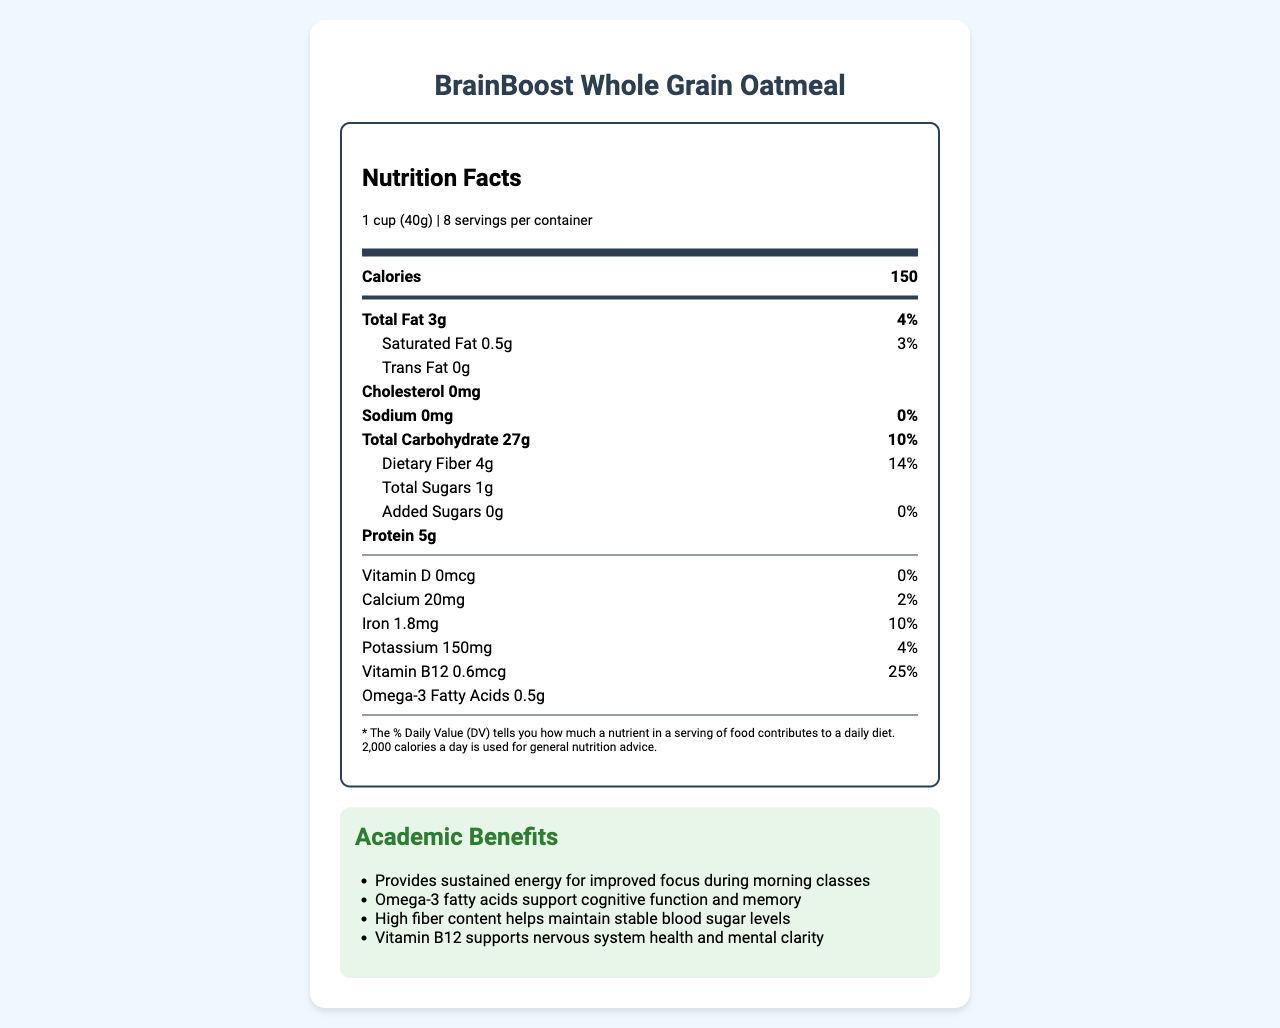who is the manufacturer of the BrainBoost Whole Grain Oatmeal? The manufacturer is listed at the end of the document under the "manufacturer" section.
Answer: NutriSmart Foods, Inc. what is the serving size of the BrainBoost Whole Grain Oatmeal? The serving size is noted near the top of the nutrition label.
Answer: 1 cup (40g) how much dietary fiber is in one serving? The amount of dietary fiber is listed under the "Total Carbohydrate" section in the nutrition facts.
Answer: 4g what is the daily value percentage for iron? The daily value percentage for iron is listed under the "Iron" section in the nutrition facts.
Answer: 10% how many servings are there per container? The number of servings per container is indicated at the top of the nutrition label.
Answer: 8 which vitamin is specifically mentioned as supporting nervous system health and mental clarity?  
A. Vitamin D  
B. Calcium  
C. Vitamin B12 Vitamin B12 is the vitamin specifically mentioned for supporting nervous system health and mental clarity based on the academic benefits section.
Answer: C which of the following health claims is true about the BrainBoost Whole Grain Oatmeal?  
I. High in sodium  
II. Contains omega-3 fatty acids for brain health  
III. No added sugars  
IV. Excellent source of whole grains The health claims are listed near the bottom and "Contains omega-3 fatty acids for brain health," "No added sugars," and "Excellent source of whole grains" are true. "High in sodium" is false.
Answer: II, III, IV is BrainBoost Whole Grain Oatmeal Non-GMO? The certification section mentions that the product is Non-GMO Project Verified.
Answer: Yes does the product contain any trans fat? The nutrition facts explicitly state that the product contains 0g of trans fat.
Answer: No summarize the main academic benefits of BrainBoost Whole Grain Oatmeal. The academic benefits section lists several benefits: sustained energy, cognitive support from omega-3 fatty acids, stable blood sugar management from fiber, and nervous system and mental clarity support from Vitamin B12.
Answer: The main academic benefits include providing sustained energy for improved focus during morning classes, supporting cognitive function and memory with omega-3 fatty acids, maintaining stable blood sugar levels with high fiber content, and enhancing nervous system health and mental clarity with Vitamin B12. what is the specific amount of Vitamin D in one serving? The amount of Vitamin D is listed under the nutrient information and is given as 0mcg.
Answer: 0mcg what is the name of the product? The product name is prominently displayed at the top of the document.
Answer: BrainBoost Whole Grain Oatmeal what is the preparation instruction for the BrainBoost Whole Grain Oatmeal? The preparation instructions can be found at the bottom section of the document.
Answer: Mix 1 cup (40g) of BrainBoost Whole Grain Oatmeal with 3/4 cup (180ml) of hot water or milk. Stir and let stand for 2 minutes before serving. what is the total calorie count for each serving? The calorie count is listed at the top of the nutrition facts section.
Answer: 150 how much omega-3 fatty acids does one serving of BrainBoost Whole Grain Oatmeal contain? The amount of omega-3 fatty acids is listed under the nutrient information section.
Answer: 0.5g can you determine the cost of the BrainBoost Whole Grain Oatmeal from this document? The document does not provide any pricing or cost information for the product.
Answer: Cannot be determined 